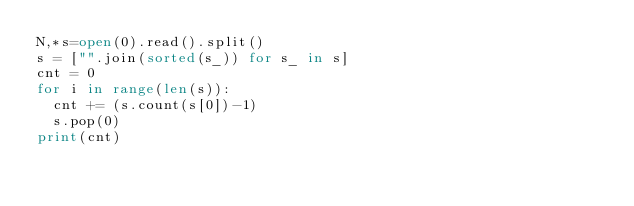Convert code to text. <code><loc_0><loc_0><loc_500><loc_500><_Python_>N,*s=open(0).read().split()
s = ["".join(sorted(s_)) for s_ in s]
cnt = 0
for i in range(len(s)):
  cnt += (s.count(s[0])-1)
  s.pop(0)
print(cnt)</code> 